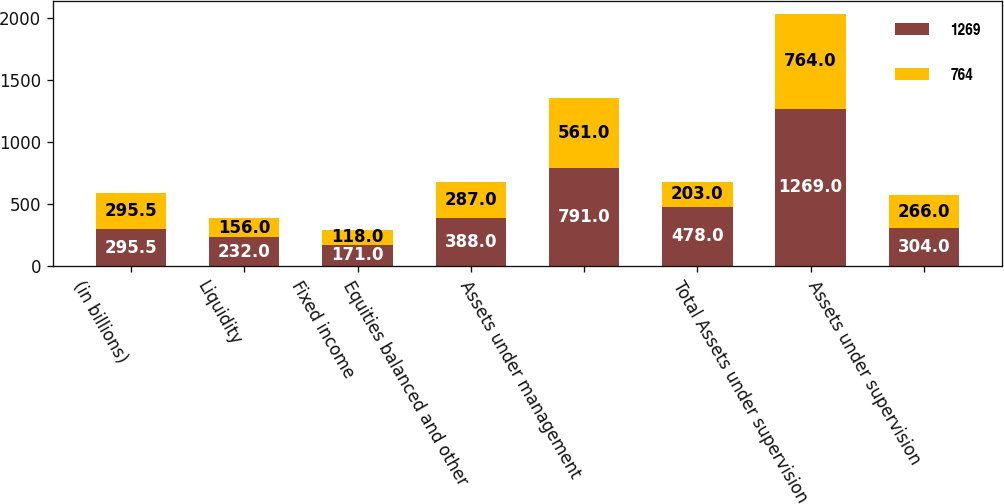Convert chart to OTSL. <chart><loc_0><loc_0><loc_500><loc_500><stacked_bar_chart><ecel><fcel>(in billions)<fcel>Liquidity<fcel>Fixed income<fcel>Equities balanced and other<fcel>Assets under management<fcel>Unnamed: 6<fcel>Total Assets under supervision<fcel>Assets under supervision<nl><fcel>1269<fcel>295.5<fcel>232<fcel>171<fcel>388<fcel>791<fcel>478<fcel>1269<fcel>304<nl><fcel>764<fcel>295.5<fcel>156<fcel>118<fcel>287<fcel>561<fcel>203<fcel>764<fcel>266<nl></chart> 